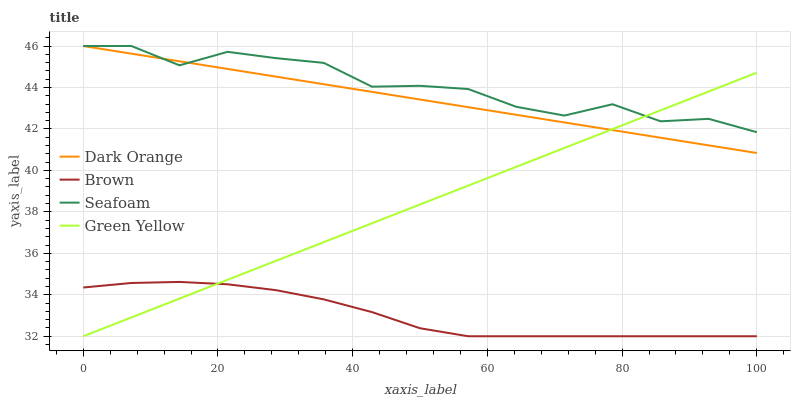Does Brown have the minimum area under the curve?
Answer yes or no. Yes. Does Seafoam have the maximum area under the curve?
Answer yes or no. Yes. Does Green Yellow have the minimum area under the curve?
Answer yes or no. No. Does Green Yellow have the maximum area under the curve?
Answer yes or no. No. Is Green Yellow the smoothest?
Answer yes or no. Yes. Is Seafoam the roughest?
Answer yes or no. Yes. Is Seafoam the smoothest?
Answer yes or no. No. Is Green Yellow the roughest?
Answer yes or no. No. Does Green Yellow have the lowest value?
Answer yes or no. Yes. Does Seafoam have the lowest value?
Answer yes or no. No. Does Seafoam have the highest value?
Answer yes or no. Yes. Does Green Yellow have the highest value?
Answer yes or no. No. Is Brown less than Seafoam?
Answer yes or no. Yes. Is Seafoam greater than Brown?
Answer yes or no. Yes. Does Seafoam intersect Dark Orange?
Answer yes or no. Yes. Is Seafoam less than Dark Orange?
Answer yes or no. No. Is Seafoam greater than Dark Orange?
Answer yes or no. No. Does Brown intersect Seafoam?
Answer yes or no. No. 